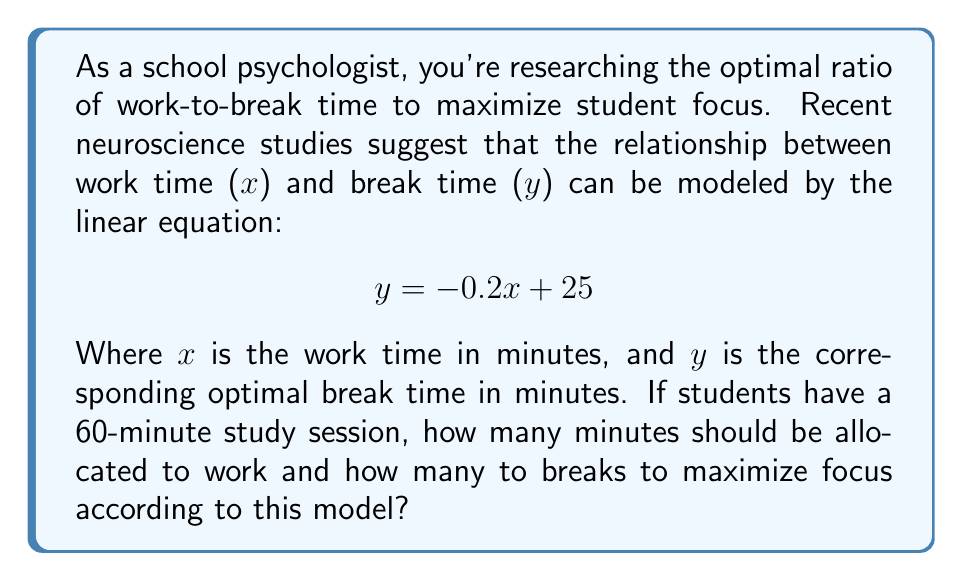Help me with this question. To solve this problem, we need to:

1. Understand that the total time is 60 minutes, so x + y = 60
2. Substitute the equation for y into this total time equation
3. Solve for x (work time)
4. Calculate y (break time) using the original equation

Step 1: Total time equation
$$ x + y = 60 $$

Step 2: Substitute y with -0.2x + 25
$$ x + (-0.2x + 25) = 60 $$

Step 3: Solve for x
$$ x - 0.2x + 25 = 60 $$
$$ 0.8x + 25 = 60 $$
$$ 0.8x = 35 $$
$$ x = 35 / 0.8 = 43.75 $$

Step 4: Calculate y using the original equation
$$ y = -0.2(43.75) + 25 $$
$$ y = -8.75 + 25 = 16.25 $$

Therefore, the optimal work time is 43.75 minutes, and the optimal break time is 16.25 minutes.
Answer: Work time: 43.75 minutes
Break time: 16.25 minutes
Ratio of work-to-break time: 43.75:16.25 or 2.69:1 